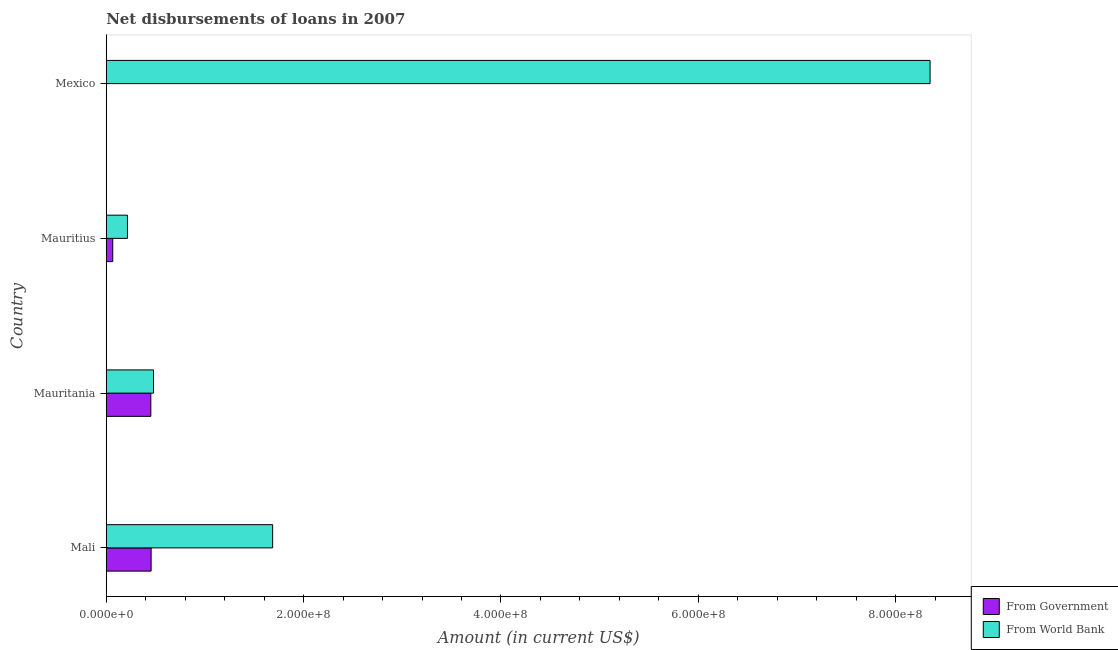What is the label of the 4th group of bars from the top?
Your answer should be compact. Mali. What is the net disbursements of loan from world bank in Mexico?
Make the answer very short. 8.35e+08. Across all countries, what is the maximum net disbursements of loan from government?
Provide a succinct answer. 4.55e+07. Across all countries, what is the minimum net disbursements of loan from world bank?
Keep it short and to the point. 2.15e+07. In which country was the net disbursements of loan from government maximum?
Keep it short and to the point. Mali. What is the total net disbursements of loan from government in the graph?
Offer a terse response. 9.72e+07. What is the difference between the net disbursements of loan from world bank in Mali and that in Mauritania?
Keep it short and to the point. 1.21e+08. What is the difference between the net disbursements of loan from government in Mexico and the net disbursements of loan from world bank in Mauritania?
Ensure brevity in your answer.  -4.79e+07. What is the average net disbursements of loan from government per country?
Ensure brevity in your answer.  2.43e+07. What is the difference between the net disbursements of loan from government and net disbursements of loan from world bank in Mauritania?
Your answer should be very brief. -2.70e+06. What is the ratio of the net disbursements of loan from world bank in Mali to that in Mauritania?
Ensure brevity in your answer.  3.52. Is the net disbursements of loan from world bank in Mali less than that in Mexico?
Offer a terse response. Yes. Is the difference between the net disbursements of loan from government in Mali and Mauritania greater than the difference between the net disbursements of loan from world bank in Mali and Mauritania?
Give a very brief answer. No. What is the difference between the highest and the second highest net disbursements of loan from government?
Keep it short and to the point. 2.99e+05. What is the difference between the highest and the lowest net disbursements of loan from government?
Provide a succinct answer. 4.55e+07. In how many countries, is the net disbursements of loan from world bank greater than the average net disbursements of loan from world bank taken over all countries?
Offer a terse response. 1. Is the sum of the net disbursements of loan from world bank in Mauritius and Mexico greater than the maximum net disbursements of loan from government across all countries?
Give a very brief answer. Yes. How many bars are there?
Offer a very short reply. 7. How many countries are there in the graph?
Provide a succinct answer. 4. Does the graph contain any zero values?
Your answer should be very brief. Yes. Does the graph contain grids?
Offer a very short reply. No. Where does the legend appear in the graph?
Keep it short and to the point. Bottom right. How many legend labels are there?
Provide a succinct answer. 2. What is the title of the graph?
Make the answer very short. Net disbursements of loans in 2007. What is the label or title of the Y-axis?
Provide a short and direct response. Country. What is the Amount (in current US$) in From Government in Mali?
Provide a short and direct response. 4.55e+07. What is the Amount (in current US$) of From World Bank in Mali?
Make the answer very short. 1.69e+08. What is the Amount (in current US$) of From Government in Mauritania?
Your answer should be compact. 4.52e+07. What is the Amount (in current US$) in From World Bank in Mauritania?
Make the answer very short. 4.79e+07. What is the Amount (in current US$) in From Government in Mauritius?
Your answer should be compact. 6.59e+06. What is the Amount (in current US$) in From World Bank in Mauritius?
Ensure brevity in your answer.  2.15e+07. What is the Amount (in current US$) in From World Bank in Mexico?
Ensure brevity in your answer.  8.35e+08. Across all countries, what is the maximum Amount (in current US$) in From Government?
Your response must be concise. 4.55e+07. Across all countries, what is the maximum Amount (in current US$) in From World Bank?
Provide a succinct answer. 8.35e+08. Across all countries, what is the minimum Amount (in current US$) in From Government?
Your answer should be very brief. 0. Across all countries, what is the minimum Amount (in current US$) in From World Bank?
Your response must be concise. 2.15e+07. What is the total Amount (in current US$) of From Government in the graph?
Make the answer very short. 9.72e+07. What is the total Amount (in current US$) in From World Bank in the graph?
Offer a very short reply. 1.07e+09. What is the difference between the Amount (in current US$) in From Government in Mali and that in Mauritania?
Keep it short and to the point. 2.99e+05. What is the difference between the Amount (in current US$) in From World Bank in Mali and that in Mauritania?
Give a very brief answer. 1.21e+08. What is the difference between the Amount (in current US$) in From Government in Mali and that in Mauritius?
Ensure brevity in your answer.  3.89e+07. What is the difference between the Amount (in current US$) of From World Bank in Mali and that in Mauritius?
Your response must be concise. 1.47e+08. What is the difference between the Amount (in current US$) in From World Bank in Mali and that in Mexico?
Provide a short and direct response. -6.66e+08. What is the difference between the Amount (in current US$) in From Government in Mauritania and that in Mauritius?
Give a very brief answer. 3.86e+07. What is the difference between the Amount (in current US$) in From World Bank in Mauritania and that in Mauritius?
Offer a very short reply. 2.64e+07. What is the difference between the Amount (in current US$) of From World Bank in Mauritania and that in Mexico?
Provide a short and direct response. -7.87e+08. What is the difference between the Amount (in current US$) of From World Bank in Mauritius and that in Mexico?
Your answer should be compact. -8.13e+08. What is the difference between the Amount (in current US$) in From Government in Mali and the Amount (in current US$) in From World Bank in Mauritania?
Keep it short and to the point. -2.40e+06. What is the difference between the Amount (in current US$) of From Government in Mali and the Amount (in current US$) of From World Bank in Mauritius?
Provide a succinct answer. 2.40e+07. What is the difference between the Amount (in current US$) in From Government in Mali and the Amount (in current US$) in From World Bank in Mexico?
Your answer should be very brief. -7.89e+08. What is the difference between the Amount (in current US$) in From Government in Mauritania and the Amount (in current US$) in From World Bank in Mauritius?
Ensure brevity in your answer.  2.37e+07. What is the difference between the Amount (in current US$) of From Government in Mauritania and the Amount (in current US$) of From World Bank in Mexico?
Offer a terse response. -7.90e+08. What is the difference between the Amount (in current US$) in From Government in Mauritius and the Amount (in current US$) in From World Bank in Mexico?
Your answer should be compact. -8.28e+08. What is the average Amount (in current US$) of From Government per country?
Ensure brevity in your answer.  2.43e+07. What is the average Amount (in current US$) of From World Bank per country?
Offer a very short reply. 2.68e+08. What is the difference between the Amount (in current US$) of From Government and Amount (in current US$) of From World Bank in Mali?
Offer a very short reply. -1.23e+08. What is the difference between the Amount (in current US$) of From Government and Amount (in current US$) of From World Bank in Mauritania?
Give a very brief answer. -2.70e+06. What is the difference between the Amount (in current US$) in From Government and Amount (in current US$) in From World Bank in Mauritius?
Your response must be concise. -1.49e+07. What is the ratio of the Amount (in current US$) of From Government in Mali to that in Mauritania?
Keep it short and to the point. 1.01. What is the ratio of the Amount (in current US$) of From World Bank in Mali to that in Mauritania?
Your answer should be compact. 3.52. What is the ratio of the Amount (in current US$) of From Government in Mali to that in Mauritius?
Ensure brevity in your answer.  6.9. What is the ratio of the Amount (in current US$) in From World Bank in Mali to that in Mauritius?
Your response must be concise. 7.84. What is the ratio of the Amount (in current US$) in From World Bank in Mali to that in Mexico?
Your answer should be compact. 0.2. What is the ratio of the Amount (in current US$) in From Government in Mauritania to that in Mauritius?
Offer a terse response. 6.85. What is the ratio of the Amount (in current US$) of From World Bank in Mauritania to that in Mauritius?
Ensure brevity in your answer.  2.23. What is the ratio of the Amount (in current US$) in From World Bank in Mauritania to that in Mexico?
Your response must be concise. 0.06. What is the ratio of the Amount (in current US$) in From World Bank in Mauritius to that in Mexico?
Your response must be concise. 0.03. What is the difference between the highest and the second highest Amount (in current US$) in From Government?
Offer a very short reply. 2.99e+05. What is the difference between the highest and the second highest Amount (in current US$) in From World Bank?
Provide a succinct answer. 6.66e+08. What is the difference between the highest and the lowest Amount (in current US$) of From Government?
Keep it short and to the point. 4.55e+07. What is the difference between the highest and the lowest Amount (in current US$) of From World Bank?
Your answer should be compact. 8.13e+08. 